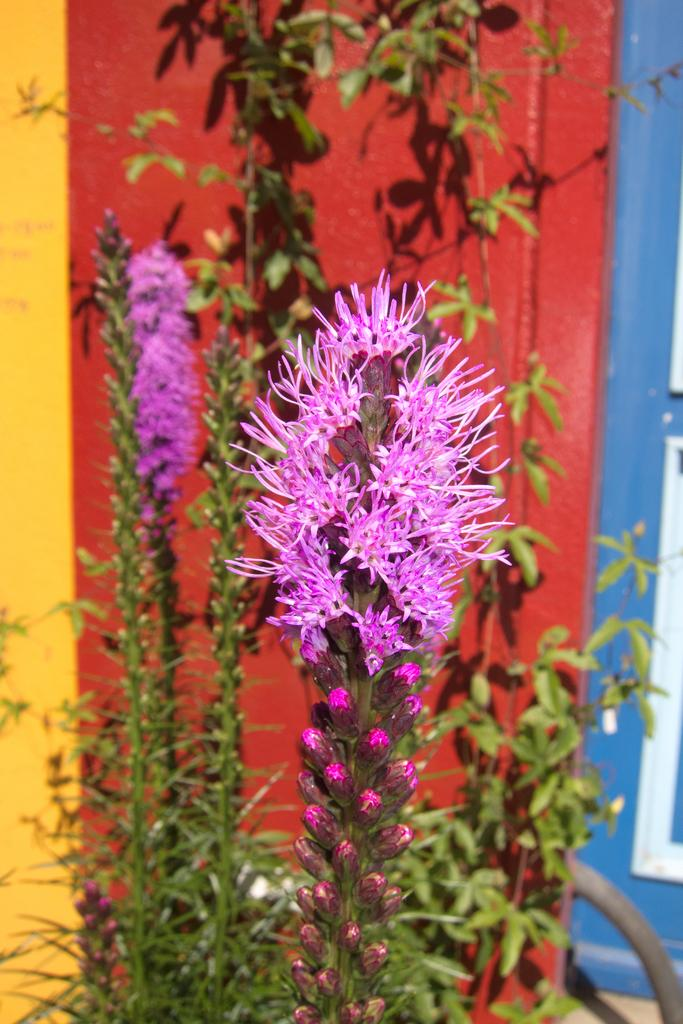What is the main subject in the center of the image? There are plants in the center of the image. What can be seen among the plants? Flowers are present among the plants. What is visible in the background of the image? There is a wall in the background of the image. How many clocks can be seen hanging from the tail of the plant in the image? There is no tail or clocks present in the image; it features plants and flowers. 